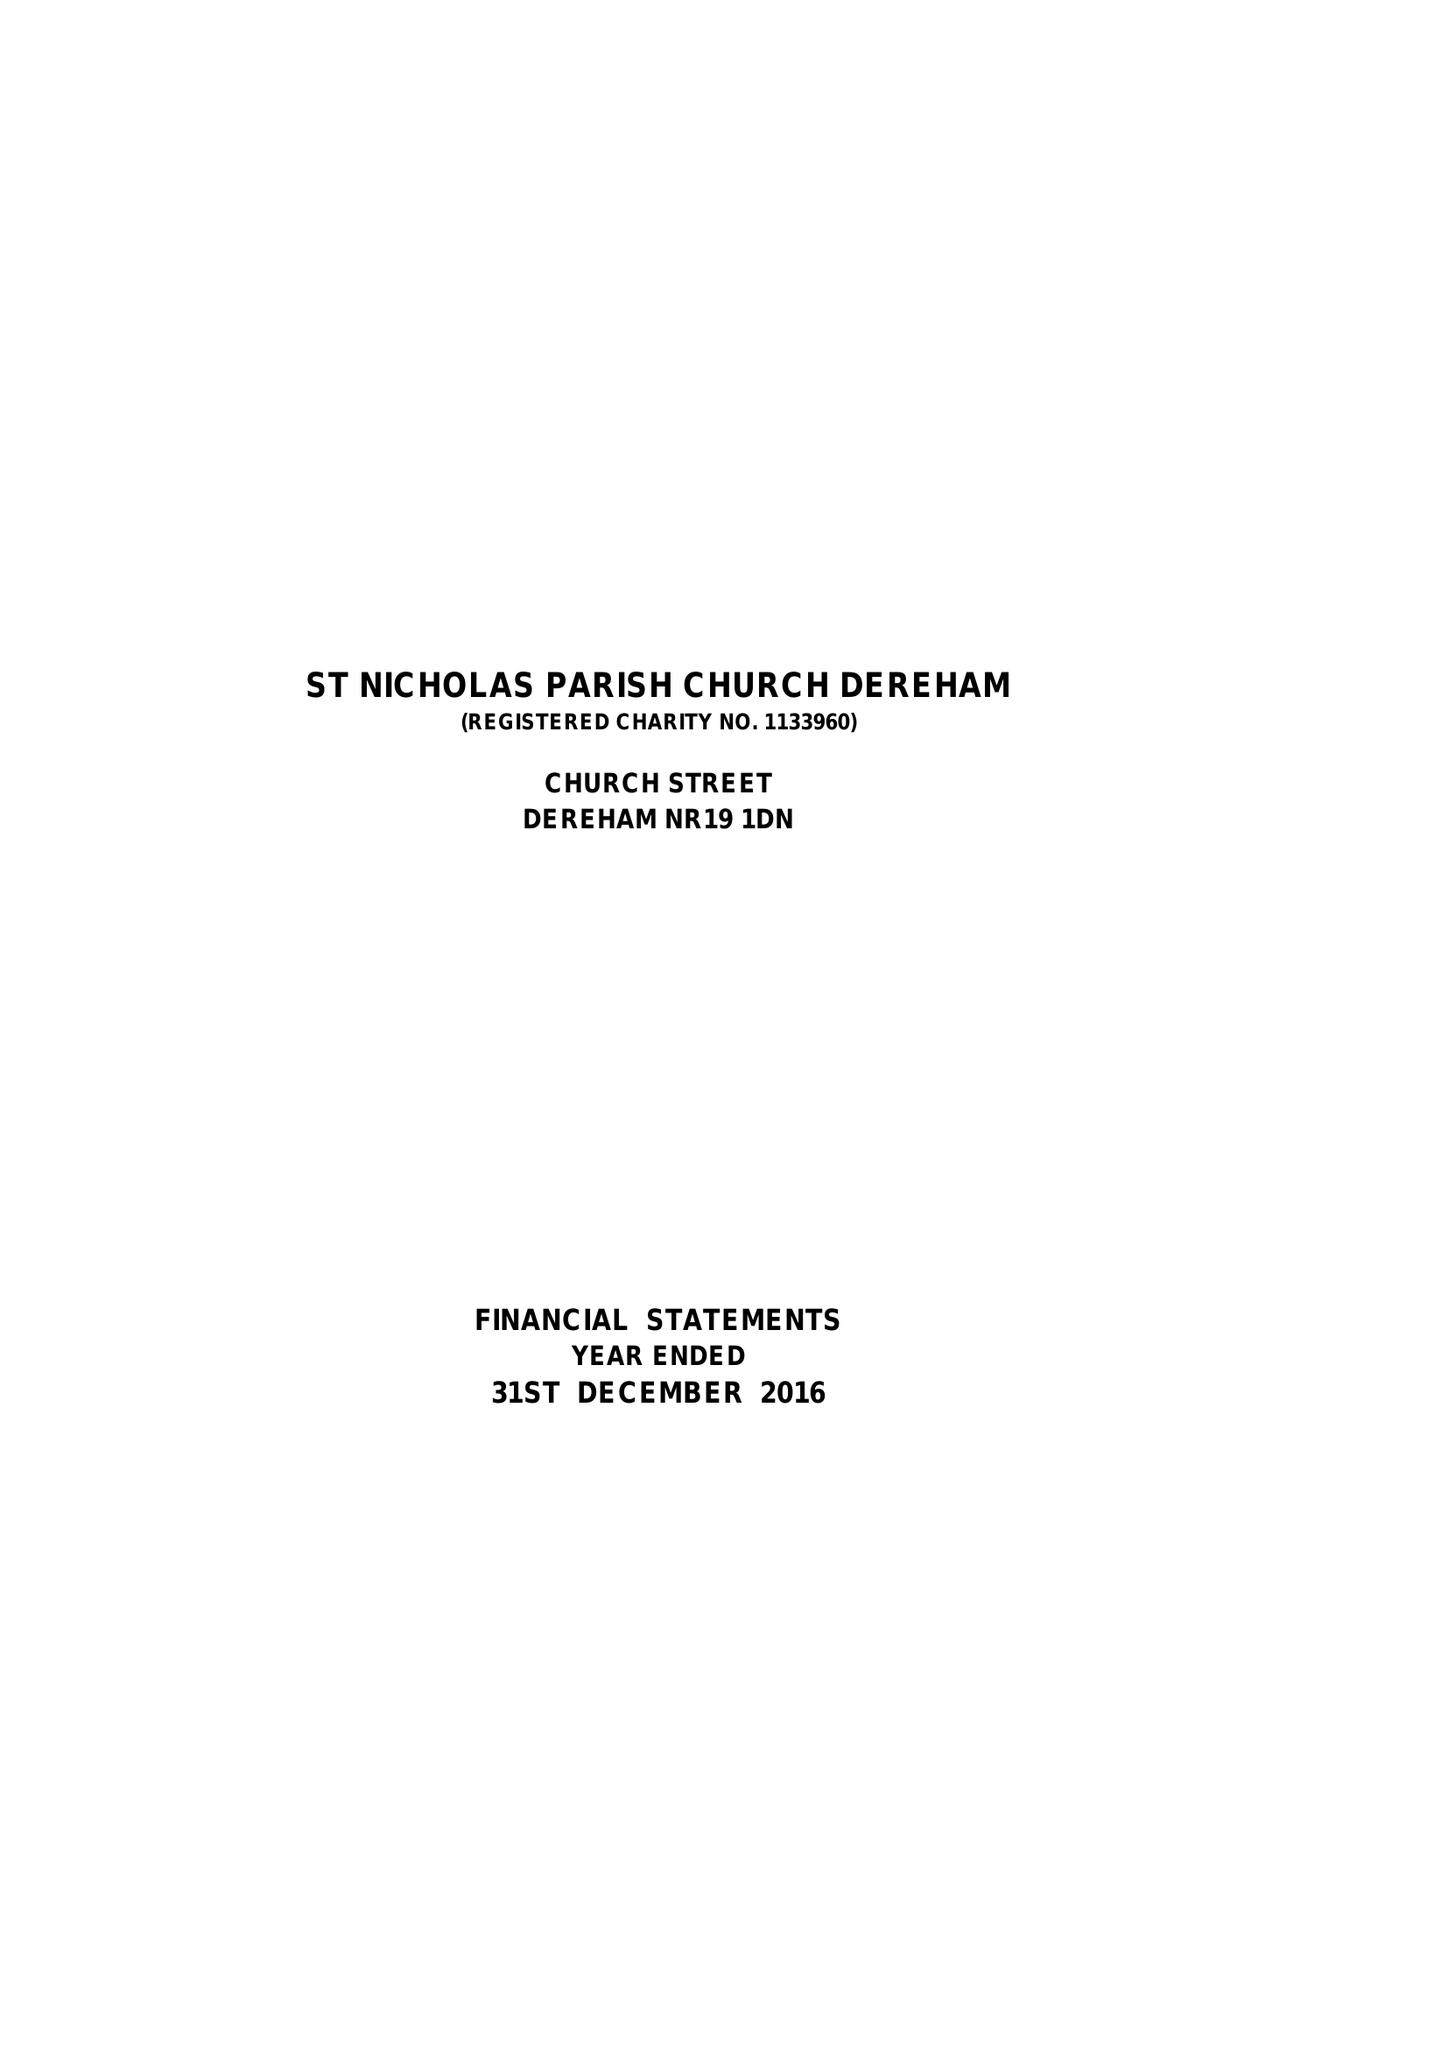What is the value for the address__post_town?
Answer the question using a single word or phrase. DEREHAM 